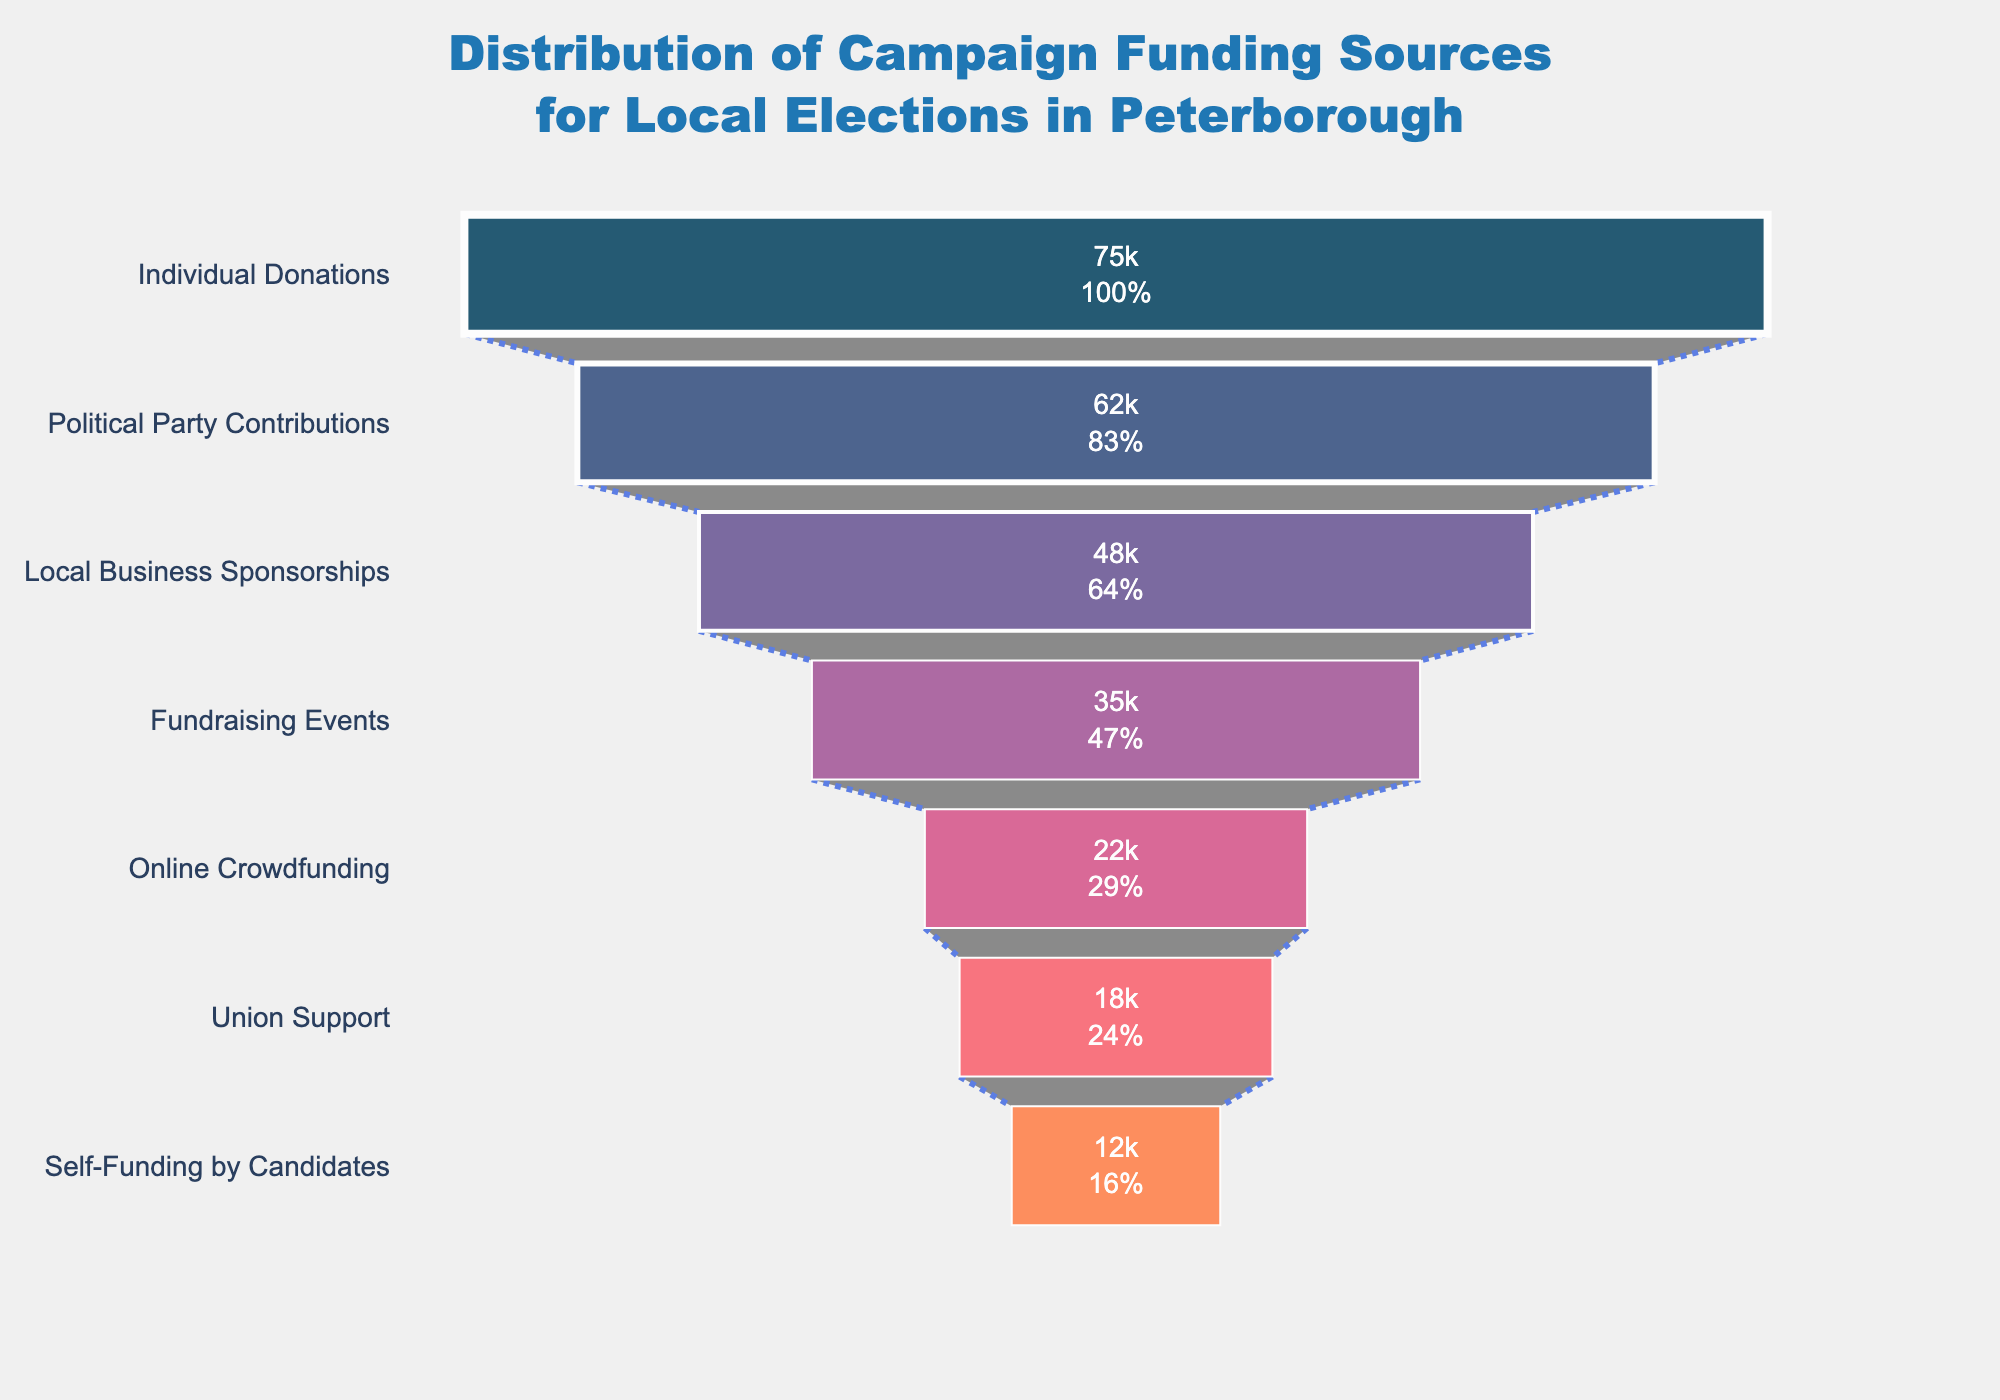What is the title of the chart? The title of the chart is usually displayed at the top and provides a brief description of the content. Here, the title states, "Distribution of Campaign Funding Sources for Local Elections in Peterborough".
Answer: Distribution of Campaign Funding Sources for Local Elections in Peterborough Which funding source has the highest amount? The funnel chart ranking visually starts from the largest value at the top and goes down to the smallest. The topmost segment in the chart represents Individual Donations with £75,000.
Answer: Individual Donations How much more funding did Individual Donations receive compared to Online Crowdfunding? To find the difference, subtract the amount from Online Crowdfunding from Individual Donations: £75,000 - £22,000 = £53,000.
Answer: £53,000 Which funding source receives the smallest amount? The funnel chart is organized from the largest to the smallest funding source. The bottommost segment of the chart indicates the smallest amount, which is Self-Funding by Candidates with £12,000.
Answer: Self-Funding by Candidates What is the combined total of Political Party Contributions and Union Support? Sum the amounts of the two funding sources: Political Party Contributions (£62,000) + Union Support (£18,000) = £80,000.
Answer: £80,000 How many different funding sources are displayed in the chart? Count the number of distinct segments or categories listed in the funnel chart. There are seven categories listed.
Answer: Seven What percentage of the total funding does Local Business Sponsorships represent? First, calculate the total funding: £75,000 + £62,000 + £48,000 + £35,000 + £22,000 + £18,000 + £12,000 = £272,000. Then, divide the Local Business Sponsorships amount by the total and multiply by 100 for percentage: (£48,000 / £272,000) * 100 ≈ 17.65%.
Answer: 17.65% Which two funding sources, when combined, are greater than Fundraising Events but less than Political Party Contributions? Start by identifying the amounts of pertinent funding sources: Fundraising Events (£35,000) and Political Party Contributions (£62,000). Next, find combinations of sources meeting the criteria. Online Crowdfunding (£22,000) and Union Support (£18,000) together total £40,000, which fits the condition.
Answer: Online Crowdfunding and Union Support If you remove the highest funding source, what would be the new total amount? Remove the highest amount (Individual Donations: £75,000) from the total funding: £272,000 - £75,000 = £197,000.
Answer: £197,000 What is the average funding amount per source? Calculate the total funding and divide it by the number of sources. Total funding is £272,000, and there are seven sources: £272,000 / 7 ≈ £38,857.14.
Answer: £38,857.14 